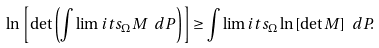<formula> <loc_0><loc_0><loc_500><loc_500>\ln { \left [ \det { \left ( \int \lim i t s _ { \Omega } M \ d P \right ) } \right ] } \geq \int \lim i t s _ { \Omega } \ln { [ \det { M } ] } \ d P .</formula> 